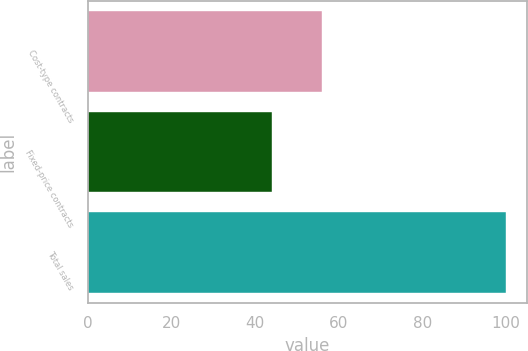<chart> <loc_0><loc_0><loc_500><loc_500><bar_chart><fcel>Cost-type contracts<fcel>Fixed-price contracts<fcel>Total sales<nl><fcel>56<fcel>44<fcel>100<nl></chart> 